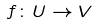Convert formula to latex. <formula><loc_0><loc_0><loc_500><loc_500>f \colon U \rightarrow V</formula> 